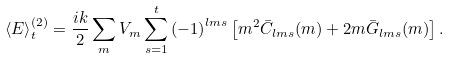Convert formula to latex. <formula><loc_0><loc_0><loc_500><loc_500>\left \langle E \right \rangle _ { t } ^ { ( 2 ) } = \frac { i k } { 2 } \sum _ { m } V _ { m } \sum _ { s = 1 } ^ { t } \left ( - 1 \right ) ^ { l m s } \left [ m ^ { 2 } \bar { C } _ { l m s } ( m ) + 2 m \bar { G } _ { l m s } ( m ) \right ] .</formula> 